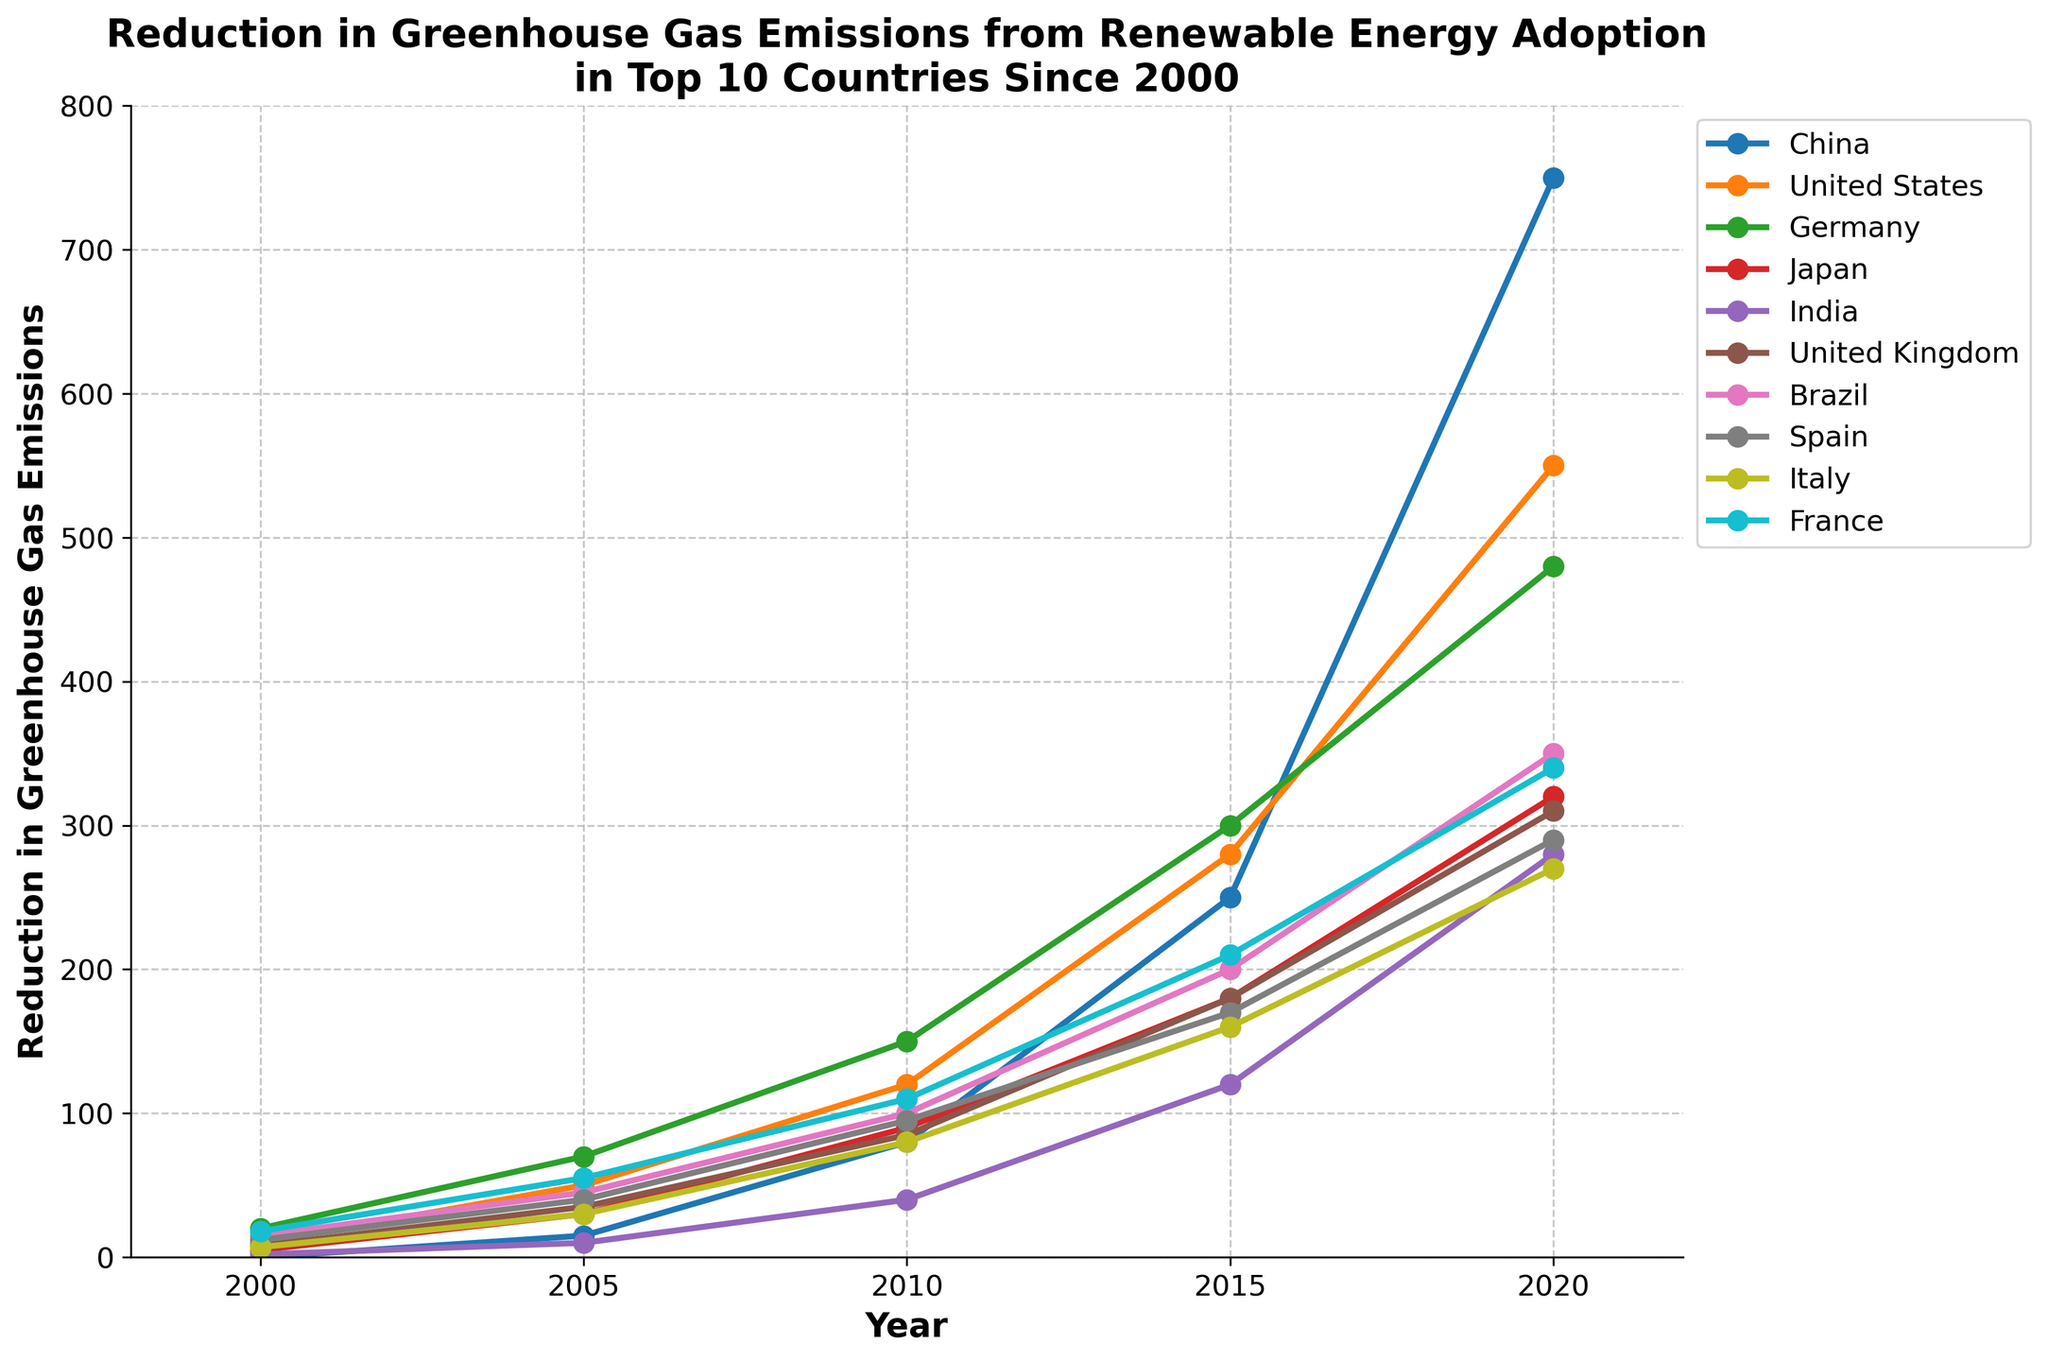What's the highest reduction in greenhouse gas emissions recorded in 2020? Identify the data points for the year 2020. The highest value is for China, at 750.
Answer: 750 Which two countries have the most similar reduction in emissions in 2015? Compare the 2015 values of each country. Spain (170) and Italy (160) are the most similar, with a difference of 10.
Answer: Spain and Italy How much greater is the reduction in emissions for the United States compared to Germany in 2005? Subtract Germany's 2005 value (70) from the United States' 2005 value (50). 50 - 70 = -20.
Answer: 20 What's the average reduction in emissions across all countries in 2010? Sum all 2010 values (80 + 120 + 150 + 90 + 40 + 85 + 100 + 95 + 80 + 110 = 950), then divide by the number of countries (10), 950 / 10 = 95.
Answer: 95 Which country shows the second-highest reduction in emissions in 2020? Identify the 2020 values and find the second-highest value, which belongs to the United States (550).
Answer: United States By how much did Japan's emissions reduction increase from 2000 to 2020? Subtract the 2000 value (5) from the 2020 value (320). 320 - 5 = 315.
Answer: 315 Which country had the least reduction in emissions in 2000? Identify the 2000 values and find the smallest value, which is for India (2).
Answer: India What's the total reduction in emissions for Brazil in all years combined? Sum Brazil's values across all years (15 + 45 + 100 + 200 + 350 = 710).
Answer: 710 How much more did China's emissions reduction increase between 2010 and 2015 compared to that of France? Calculate the increase for China (250 - 80 = 170) and France (210 - 110 = 100), then find the difference, 170 - 100 = 70.
Answer: 70 What is the range of emission reductions for the United Kingdom in 2020? Identify the maximum and minimum values for the United Kingdom and subtract them. Maximum is 310 and the minimum is 8, 310 - 8 = 302.
Answer: 302 